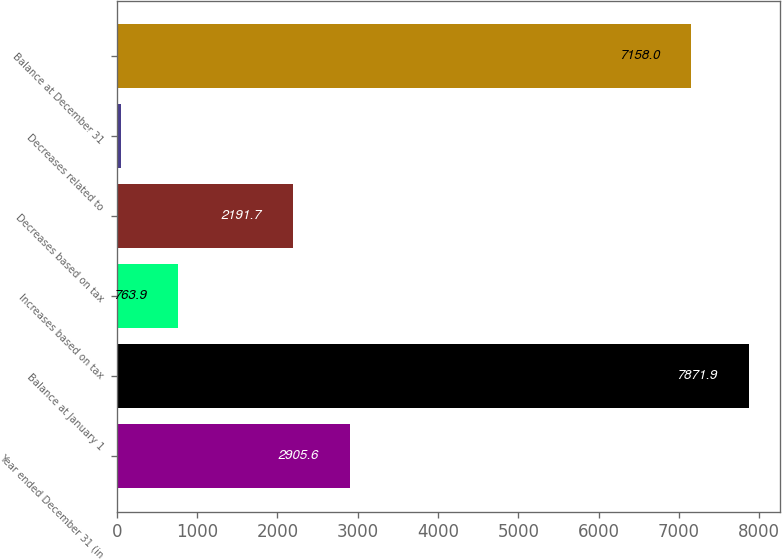Convert chart to OTSL. <chart><loc_0><loc_0><loc_500><loc_500><bar_chart><fcel>Year ended December 31 (in<fcel>Balance at January 1<fcel>Increases based on tax<fcel>Decreases based on tax<fcel>Decreases related to<fcel>Balance at December 31<nl><fcel>2905.6<fcel>7871.9<fcel>763.9<fcel>2191.7<fcel>50<fcel>7158<nl></chart> 